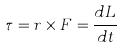Convert formula to latex. <formula><loc_0><loc_0><loc_500><loc_500>\tau = r \times F = \frac { d L } { d t }</formula> 